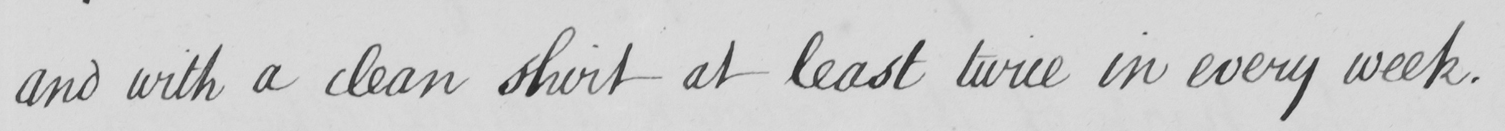Please transcribe the handwritten text in this image. and with a clean shirt at least twice in every week . 